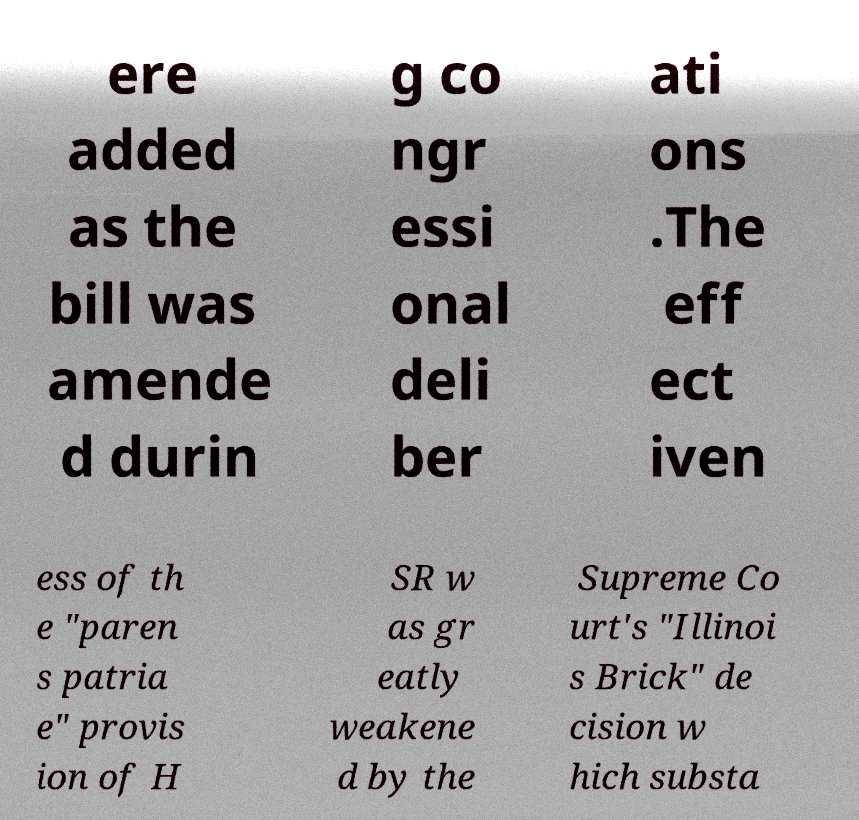For documentation purposes, I need the text within this image transcribed. Could you provide that? ere added as the bill was amende d durin g co ngr essi onal deli ber ati ons .The eff ect iven ess of th e "paren s patria e" provis ion of H SR w as gr eatly weakene d by the Supreme Co urt's "Illinoi s Brick" de cision w hich substa 